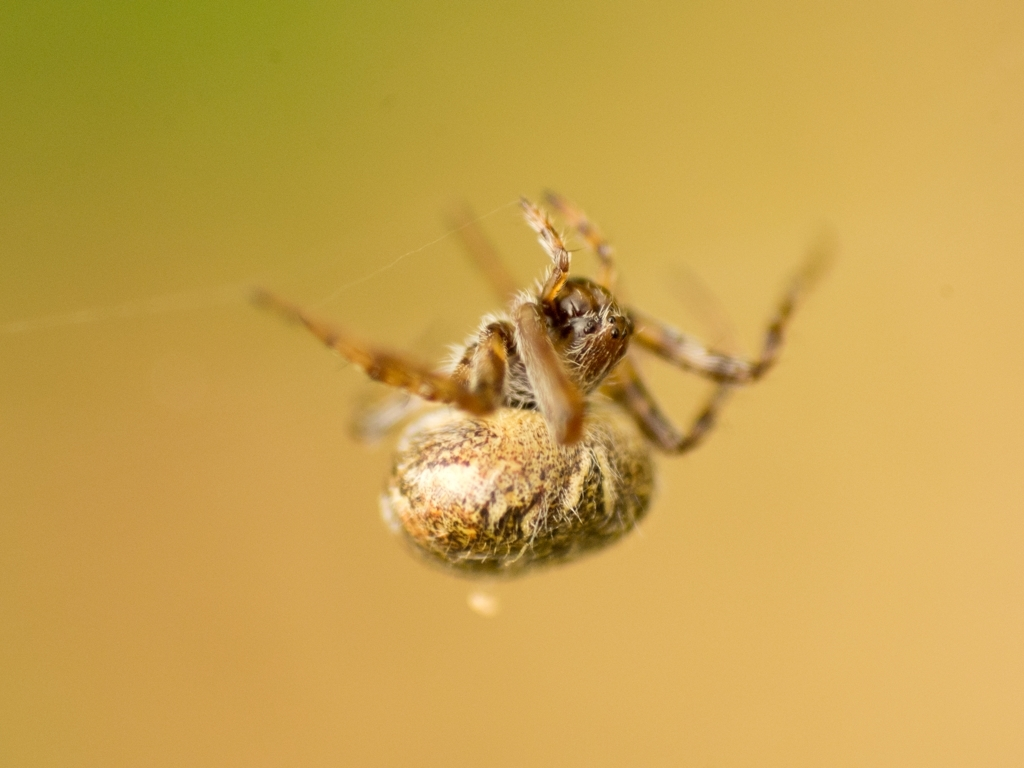How does the coloration of the spider contribute to its survival? The spider's mottled brown and tan coloration provides excellent camouflage against wood or dry leaves, which is vital for both protection from predators and to ambush prey. This form of cryptic coloration is a common adaptation in many spider species. 